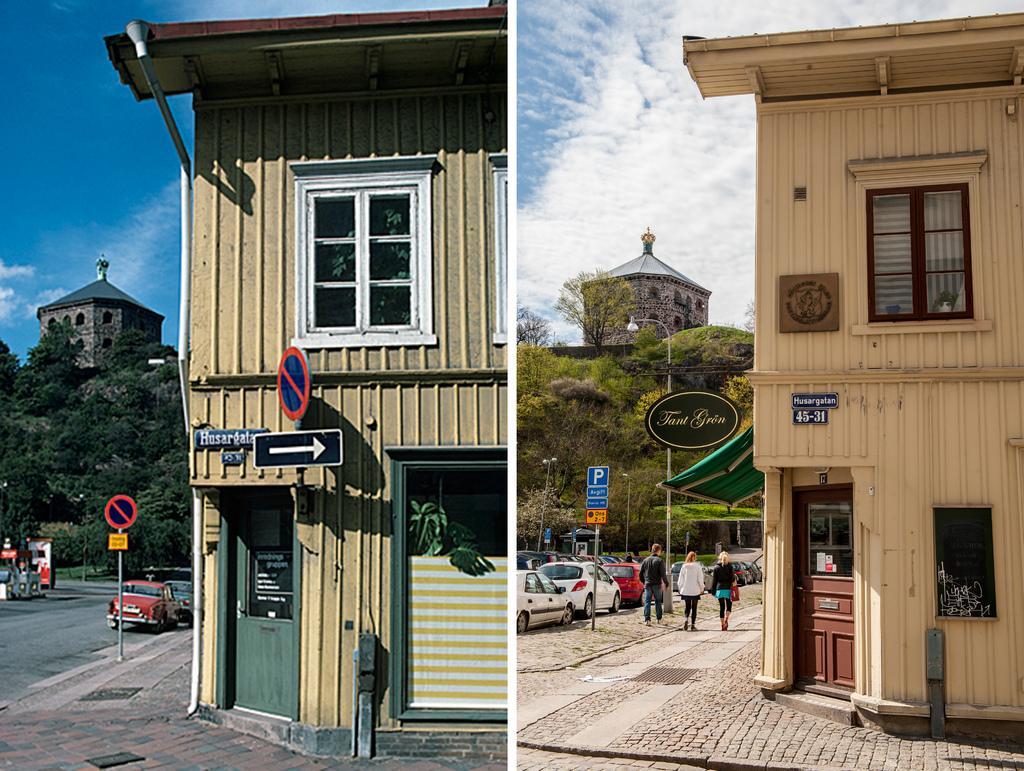Describe this image in one or two sentences. It is a collage image there are two houses in both the images and beside the house there is a footpath and there are few vehicles parked beside the footpath and behind the house there is a tree and behind the tree there is a tower. 